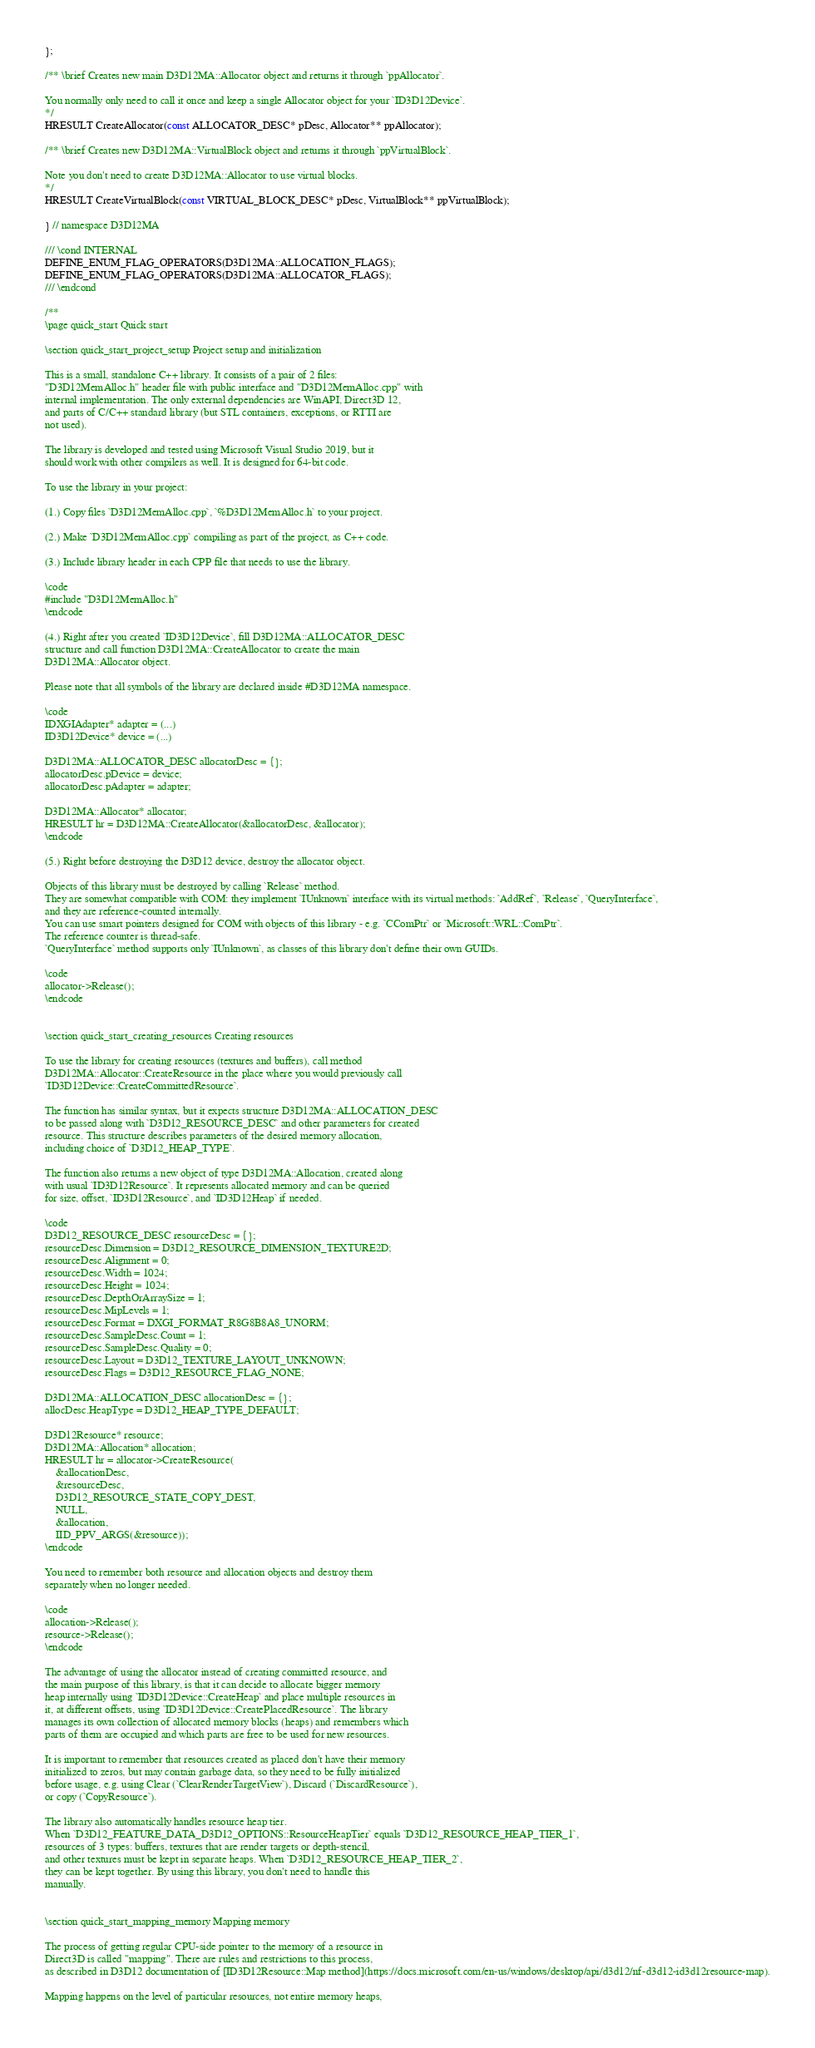<code> <loc_0><loc_0><loc_500><loc_500><_C_>};

/** \brief Creates new main D3D12MA::Allocator object and returns it through `ppAllocator`.

You normally only need to call it once and keep a single Allocator object for your `ID3D12Device`.
*/
HRESULT CreateAllocator(const ALLOCATOR_DESC* pDesc, Allocator** ppAllocator);

/** \brief Creates new D3D12MA::VirtualBlock object and returns it through `ppVirtualBlock`.

Note you don't need to create D3D12MA::Allocator to use virtual blocks.
*/
HRESULT CreateVirtualBlock(const VIRTUAL_BLOCK_DESC* pDesc, VirtualBlock** ppVirtualBlock);

} // namespace D3D12MA

/// \cond INTERNAL
DEFINE_ENUM_FLAG_OPERATORS(D3D12MA::ALLOCATION_FLAGS);
DEFINE_ENUM_FLAG_OPERATORS(D3D12MA::ALLOCATOR_FLAGS);
/// \endcond

/**
\page quick_start Quick start

\section quick_start_project_setup Project setup and initialization

This is a small, standalone C++ library. It consists of a pair of 2 files:
"D3D12MemAlloc.h" header file with public interface and "D3D12MemAlloc.cpp" with
internal implementation. The only external dependencies are WinAPI, Direct3D 12,
and parts of C/C++ standard library (but STL containers, exceptions, or RTTI are
not used).

The library is developed and tested using Microsoft Visual Studio 2019, but it
should work with other compilers as well. It is designed for 64-bit code.

To use the library in your project:

(1.) Copy files `D3D12MemAlloc.cpp`, `%D3D12MemAlloc.h` to your project.

(2.) Make `D3D12MemAlloc.cpp` compiling as part of the project, as C++ code.

(3.) Include library header in each CPP file that needs to use the library.

\code
#include "D3D12MemAlloc.h"
\endcode

(4.) Right after you created `ID3D12Device`, fill D3D12MA::ALLOCATOR_DESC
structure and call function D3D12MA::CreateAllocator to create the main
D3D12MA::Allocator object.

Please note that all symbols of the library are declared inside #D3D12MA namespace.

\code
IDXGIAdapter* adapter = (...)
ID3D12Device* device = (...)

D3D12MA::ALLOCATOR_DESC allocatorDesc = {};
allocatorDesc.pDevice = device;
allocatorDesc.pAdapter = adapter;

D3D12MA::Allocator* allocator;
HRESULT hr = D3D12MA::CreateAllocator(&allocatorDesc, &allocator);
\endcode

(5.) Right before destroying the D3D12 device, destroy the allocator object.

Objects of this library must be destroyed by calling `Release` method.
They are somewhat compatible with COM: they implement `IUnknown` interface with its virtual methods: `AddRef`, `Release`, `QueryInterface`,
and they are reference-counted internally.
You can use smart pointers designed for COM with objects of this library - e.g. `CComPtr` or `Microsoft::WRL::ComPtr`.
The reference counter is thread-safe.
`QueryInterface` method supports only `IUnknown`, as classes of this library don't define their own GUIDs.

\code
allocator->Release();
\endcode


\section quick_start_creating_resources Creating resources

To use the library for creating resources (textures and buffers), call method
D3D12MA::Allocator::CreateResource in the place where you would previously call
`ID3D12Device::CreateCommittedResource`.

The function has similar syntax, but it expects structure D3D12MA::ALLOCATION_DESC
to be passed along with `D3D12_RESOURCE_DESC` and other parameters for created
resource. This structure describes parameters of the desired memory allocation,
including choice of `D3D12_HEAP_TYPE`.

The function also returns a new object of type D3D12MA::Allocation, created along
with usual `ID3D12Resource`. It represents allocated memory and can be queried
for size, offset, `ID3D12Resource`, and `ID3D12Heap` if needed.

\code
D3D12_RESOURCE_DESC resourceDesc = {};
resourceDesc.Dimension = D3D12_RESOURCE_DIMENSION_TEXTURE2D;
resourceDesc.Alignment = 0;
resourceDesc.Width = 1024;
resourceDesc.Height = 1024;
resourceDesc.DepthOrArraySize = 1;
resourceDesc.MipLevels = 1;
resourceDesc.Format = DXGI_FORMAT_R8G8B8A8_UNORM;
resourceDesc.SampleDesc.Count = 1;
resourceDesc.SampleDesc.Quality = 0;
resourceDesc.Layout = D3D12_TEXTURE_LAYOUT_UNKNOWN;
resourceDesc.Flags = D3D12_RESOURCE_FLAG_NONE;

D3D12MA::ALLOCATION_DESC allocationDesc = {};
allocDesc.HeapType = D3D12_HEAP_TYPE_DEFAULT;

D3D12Resource* resource;
D3D12MA::Allocation* allocation;
HRESULT hr = allocator->CreateResource(
    &allocationDesc,
    &resourceDesc,
    D3D12_RESOURCE_STATE_COPY_DEST,
    NULL,
    &allocation,
    IID_PPV_ARGS(&resource));
\endcode

You need to remember both resource and allocation objects and destroy them
separately when no longer needed.

\code
allocation->Release();
resource->Release();
\endcode

The advantage of using the allocator instead of creating committed resource, and
the main purpose of this library, is that it can decide to allocate bigger memory
heap internally using `ID3D12Device::CreateHeap` and place multiple resources in
it, at different offsets, using `ID3D12Device::CreatePlacedResource`. The library
manages its own collection of allocated memory blocks (heaps) and remembers which
parts of them are occupied and which parts are free to be used for new resources.

It is important to remember that resources created as placed don't have their memory
initialized to zeros, but may contain garbage data, so they need to be fully initialized
before usage, e.g. using Clear (`ClearRenderTargetView`), Discard (`DiscardResource`),
or copy (`CopyResource`).

The library also automatically handles resource heap tier.
When `D3D12_FEATURE_DATA_D3D12_OPTIONS::ResourceHeapTier` equals `D3D12_RESOURCE_HEAP_TIER_1`,
resources of 3 types: buffers, textures that are render targets or depth-stencil,
and other textures must be kept in separate heaps. When `D3D12_RESOURCE_HEAP_TIER_2`,
they can be kept together. By using this library, you don't need to handle this
manually.


\section quick_start_mapping_memory Mapping memory

The process of getting regular CPU-side pointer to the memory of a resource in
Direct3D is called "mapping". There are rules and restrictions to this process,
as described in D3D12 documentation of [ID3D12Resource::Map method](https://docs.microsoft.com/en-us/windows/desktop/api/d3d12/nf-d3d12-id3d12resource-map).

Mapping happens on the level of particular resources, not entire memory heaps,</code> 